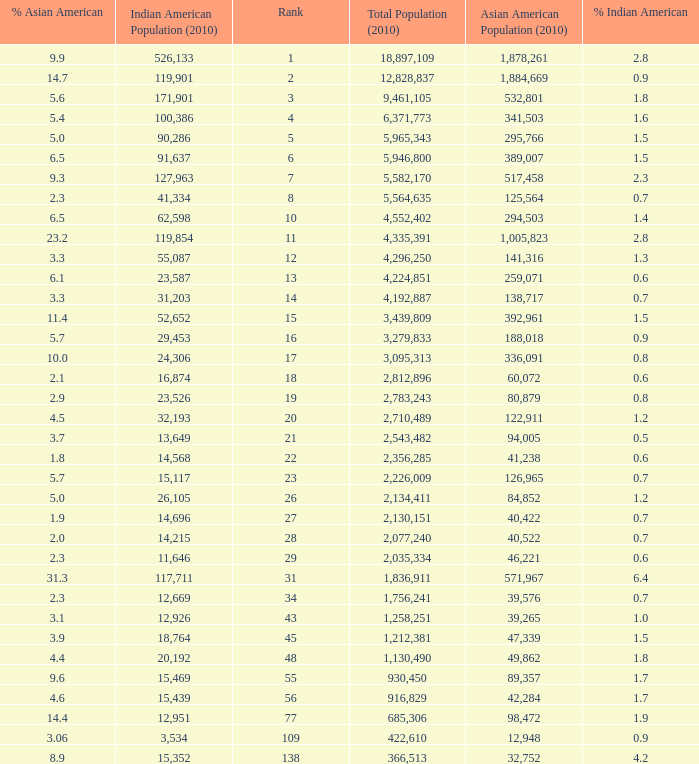What's the total population when there are 5.7% Asian American and fewer than 126,965 Asian American Population? None. Help me parse the entirety of this table. {'header': ['% Asian American', 'Indian American Population (2010)', 'Rank', 'Total Population (2010)', 'Asian American Population (2010)', '% Indian American'], 'rows': [['9.9', '526,133', '1', '18,897,109', '1,878,261', '2.8'], ['14.7', '119,901', '2', '12,828,837', '1,884,669', '0.9'], ['5.6', '171,901', '3', '9,461,105', '532,801', '1.8'], ['5.4', '100,386', '4', '6,371,773', '341,503', '1.6'], ['5.0', '90,286', '5', '5,965,343', '295,766', '1.5'], ['6.5', '91,637', '6', '5,946,800', '389,007', '1.5'], ['9.3', '127,963', '7', '5,582,170', '517,458', '2.3'], ['2.3', '41,334', '8', '5,564,635', '125,564', '0.7'], ['6.5', '62,598', '10', '4,552,402', '294,503', '1.4'], ['23.2', '119,854', '11', '4,335,391', '1,005,823', '2.8'], ['3.3', '55,087', '12', '4,296,250', '141,316', '1.3'], ['6.1', '23,587', '13', '4,224,851', '259,071', '0.6'], ['3.3', '31,203', '14', '4,192,887', '138,717', '0.7'], ['11.4', '52,652', '15', '3,439,809', '392,961', '1.5'], ['5.7', '29,453', '16', '3,279,833', '188,018', '0.9'], ['10.0', '24,306', '17', '3,095,313', '336,091', '0.8'], ['2.1', '16,874', '18', '2,812,896', '60,072', '0.6'], ['2.9', '23,526', '19', '2,783,243', '80,879', '0.8'], ['4.5', '32,193', '20', '2,710,489', '122,911', '1.2'], ['3.7', '13,649', '21', '2,543,482', '94,005', '0.5'], ['1.8', '14,568', '22', '2,356,285', '41,238', '0.6'], ['5.7', '15,117', '23', '2,226,009', '126,965', '0.7'], ['5.0', '26,105', '26', '2,134,411', '84,852', '1.2'], ['1.9', '14,696', '27', '2,130,151', '40,422', '0.7'], ['2.0', '14,215', '28', '2,077,240', '40,522', '0.7'], ['2.3', '11,646', '29', '2,035,334', '46,221', '0.6'], ['31.3', '117,711', '31', '1,836,911', '571,967', '6.4'], ['2.3', '12,669', '34', '1,756,241', '39,576', '0.7'], ['3.1', '12,926', '43', '1,258,251', '39,265', '1.0'], ['3.9', '18,764', '45', '1,212,381', '47,339', '1.5'], ['4.4', '20,192', '48', '1,130,490', '49,862', '1.8'], ['9.6', '15,469', '55', '930,450', '89,357', '1.7'], ['4.6', '15,439', '56', '916,829', '42,284', '1.7'], ['14.4', '12,951', '77', '685,306', '98,472', '1.9'], ['3.06', '3,534', '109', '422,610', '12,948', '0.9'], ['8.9', '15,352', '138', '366,513', '32,752', '4.2']]} 